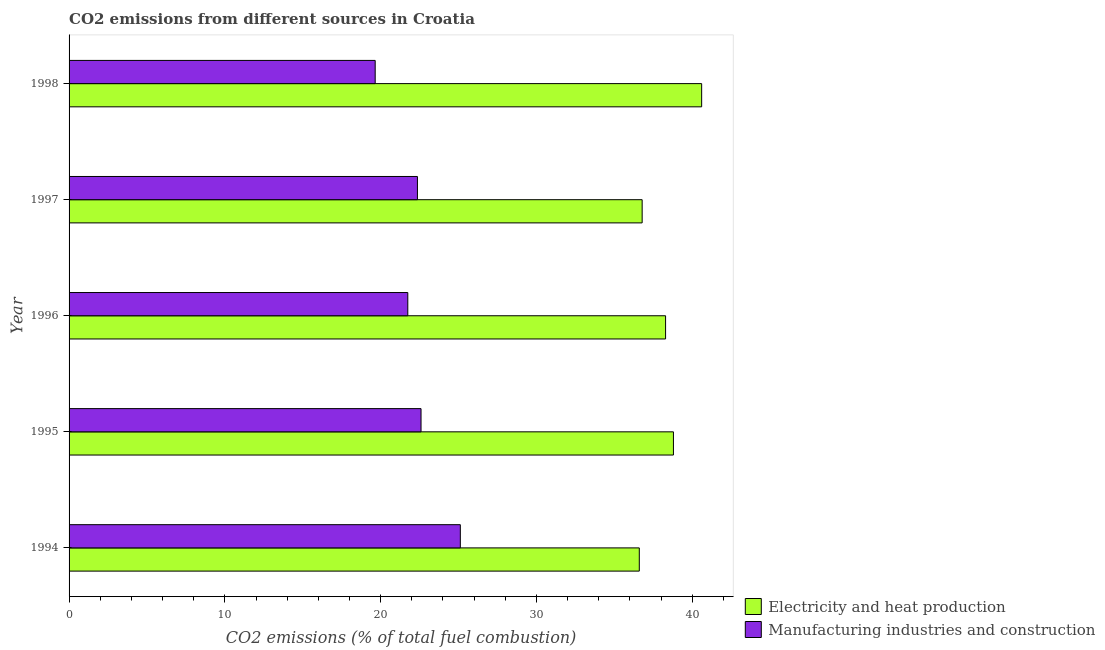Are the number of bars on each tick of the Y-axis equal?
Your answer should be very brief. Yes. How many bars are there on the 2nd tick from the top?
Offer a terse response. 2. How many bars are there on the 5th tick from the bottom?
Make the answer very short. 2. What is the label of the 1st group of bars from the top?
Provide a short and direct response. 1998. What is the co2 emissions due to electricity and heat production in 1998?
Provide a succinct answer. 40.61. Across all years, what is the maximum co2 emissions due to electricity and heat production?
Offer a terse response. 40.61. Across all years, what is the minimum co2 emissions due to manufacturing industries?
Your response must be concise. 19.65. In which year was the co2 emissions due to manufacturing industries maximum?
Ensure brevity in your answer.  1994. In which year was the co2 emissions due to manufacturing industries minimum?
Ensure brevity in your answer.  1998. What is the total co2 emissions due to manufacturing industries in the graph?
Provide a succinct answer. 111.47. What is the difference between the co2 emissions due to electricity and heat production in 1996 and that in 1998?
Provide a short and direct response. -2.32. What is the difference between the co2 emissions due to electricity and heat production in 1997 and the co2 emissions due to manufacturing industries in 1996?
Offer a terse response. 15.05. What is the average co2 emissions due to manufacturing industries per year?
Offer a terse response. 22.29. In the year 1996, what is the difference between the co2 emissions due to electricity and heat production and co2 emissions due to manufacturing industries?
Your response must be concise. 16.55. What is the ratio of the co2 emissions due to manufacturing industries in 1994 to that in 1995?
Provide a succinct answer. 1.11. Is the co2 emissions due to manufacturing industries in 1995 less than that in 1997?
Ensure brevity in your answer.  No. Is the difference between the co2 emissions due to manufacturing industries in 1996 and 1998 greater than the difference between the co2 emissions due to electricity and heat production in 1996 and 1998?
Your answer should be very brief. Yes. What is the difference between the highest and the second highest co2 emissions due to electricity and heat production?
Your answer should be compact. 1.81. What is the difference between the highest and the lowest co2 emissions due to manufacturing industries?
Offer a very short reply. 5.47. Is the sum of the co2 emissions due to manufacturing industries in 1994 and 1996 greater than the maximum co2 emissions due to electricity and heat production across all years?
Offer a very short reply. Yes. What does the 1st bar from the top in 1994 represents?
Make the answer very short. Manufacturing industries and construction. What does the 2nd bar from the bottom in 1997 represents?
Your answer should be compact. Manufacturing industries and construction. How many bars are there?
Offer a very short reply. 10. How many years are there in the graph?
Offer a very short reply. 5. Are the values on the major ticks of X-axis written in scientific E-notation?
Provide a succinct answer. No. What is the title of the graph?
Keep it short and to the point. CO2 emissions from different sources in Croatia. Does "Public credit registry" appear as one of the legend labels in the graph?
Ensure brevity in your answer.  No. What is the label or title of the X-axis?
Ensure brevity in your answer.  CO2 emissions (% of total fuel combustion). What is the label or title of the Y-axis?
Keep it short and to the point. Year. What is the CO2 emissions (% of total fuel combustion) in Electricity and heat production in 1994?
Ensure brevity in your answer.  36.61. What is the CO2 emissions (% of total fuel combustion) in Manufacturing industries and construction in 1994?
Ensure brevity in your answer.  25.12. What is the CO2 emissions (% of total fuel combustion) in Electricity and heat production in 1995?
Offer a very short reply. 38.8. What is the CO2 emissions (% of total fuel combustion) of Manufacturing industries and construction in 1995?
Give a very brief answer. 22.59. What is the CO2 emissions (% of total fuel combustion) of Electricity and heat production in 1996?
Ensure brevity in your answer.  38.29. What is the CO2 emissions (% of total fuel combustion) of Manufacturing industries and construction in 1996?
Ensure brevity in your answer.  21.74. What is the CO2 emissions (% of total fuel combustion) of Electricity and heat production in 1997?
Your response must be concise. 36.79. What is the CO2 emissions (% of total fuel combustion) in Manufacturing industries and construction in 1997?
Offer a terse response. 22.36. What is the CO2 emissions (% of total fuel combustion) of Electricity and heat production in 1998?
Make the answer very short. 40.61. What is the CO2 emissions (% of total fuel combustion) in Manufacturing industries and construction in 1998?
Make the answer very short. 19.65. Across all years, what is the maximum CO2 emissions (% of total fuel combustion) of Electricity and heat production?
Keep it short and to the point. 40.61. Across all years, what is the maximum CO2 emissions (% of total fuel combustion) in Manufacturing industries and construction?
Provide a short and direct response. 25.12. Across all years, what is the minimum CO2 emissions (% of total fuel combustion) in Electricity and heat production?
Offer a terse response. 36.61. Across all years, what is the minimum CO2 emissions (% of total fuel combustion) of Manufacturing industries and construction?
Offer a very short reply. 19.65. What is the total CO2 emissions (% of total fuel combustion) of Electricity and heat production in the graph?
Your response must be concise. 191.1. What is the total CO2 emissions (% of total fuel combustion) in Manufacturing industries and construction in the graph?
Your answer should be compact. 111.47. What is the difference between the CO2 emissions (% of total fuel combustion) of Electricity and heat production in 1994 and that in 1995?
Offer a very short reply. -2.19. What is the difference between the CO2 emissions (% of total fuel combustion) in Manufacturing industries and construction in 1994 and that in 1995?
Ensure brevity in your answer.  2.52. What is the difference between the CO2 emissions (% of total fuel combustion) in Electricity and heat production in 1994 and that in 1996?
Your answer should be compact. -1.69. What is the difference between the CO2 emissions (% of total fuel combustion) in Manufacturing industries and construction in 1994 and that in 1996?
Ensure brevity in your answer.  3.37. What is the difference between the CO2 emissions (% of total fuel combustion) of Electricity and heat production in 1994 and that in 1997?
Your response must be concise. -0.18. What is the difference between the CO2 emissions (% of total fuel combustion) of Manufacturing industries and construction in 1994 and that in 1997?
Your answer should be compact. 2.75. What is the difference between the CO2 emissions (% of total fuel combustion) in Electricity and heat production in 1994 and that in 1998?
Give a very brief answer. -4. What is the difference between the CO2 emissions (% of total fuel combustion) in Manufacturing industries and construction in 1994 and that in 1998?
Offer a very short reply. 5.47. What is the difference between the CO2 emissions (% of total fuel combustion) in Electricity and heat production in 1995 and that in 1996?
Offer a very short reply. 0.5. What is the difference between the CO2 emissions (% of total fuel combustion) of Manufacturing industries and construction in 1995 and that in 1996?
Keep it short and to the point. 0.85. What is the difference between the CO2 emissions (% of total fuel combustion) of Electricity and heat production in 1995 and that in 1997?
Your answer should be very brief. 2.01. What is the difference between the CO2 emissions (% of total fuel combustion) in Manufacturing industries and construction in 1995 and that in 1997?
Ensure brevity in your answer.  0.23. What is the difference between the CO2 emissions (% of total fuel combustion) in Electricity and heat production in 1995 and that in 1998?
Provide a short and direct response. -1.81. What is the difference between the CO2 emissions (% of total fuel combustion) in Manufacturing industries and construction in 1995 and that in 1998?
Offer a terse response. 2.94. What is the difference between the CO2 emissions (% of total fuel combustion) of Electricity and heat production in 1996 and that in 1997?
Your answer should be compact. 1.5. What is the difference between the CO2 emissions (% of total fuel combustion) of Manufacturing industries and construction in 1996 and that in 1997?
Give a very brief answer. -0.62. What is the difference between the CO2 emissions (% of total fuel combustion) in Electricity and heat production in 1996 and that in 1998?
Your response must be concise. -2.32. What is the difference between the CO2 emissions (% of total fuel combustion) in Manufacturing industries and construction in 1996 and that in 1998?
Your answer should be compact. 2.09. What is the difference between the CO2 emissions (% of total fuel combustion) in Electricity and heat production in 1997 and that in 1998?
Provide a short and direct response. -3.82. What is the difference between the CO2 emissions (% of total fuel combustion) of Manufacturing industries and construction in 1997 and that in 1998?
Your response must be concise. 2.71. What is the difference between the CO2 emissions (% of total fuel combustion) of Electricity and heat production in 1994 and the CO2 emissions (% of total fuel combustion) of Manufacturing industries and construction in 1995?
Ensure brevity in your answer.  14.01. What is the difference between the CO2 emissions (% of total fuel combustion) of Electricity and heat production in 1994 and the CO2 emissions (% of total fuel combustion) of Manufacturing industries and construction in 1996?
Ensure brevity in your answer.  14.86. What is the difference between the CO2 emissions (% of total fuel combustion) of Electricity and heat production in 1994 and the CO2 emissions (% of total fuel combustion) of Manufacturing industries and construction in 1997?
Your response must be concise. 14.24. What is the difference between the CO2 emissions (% of total fuel combustion) in Electricity and heat production in 1994 and the CO2 emissions (% of total fuel combustion) in Manufacturing industries and construction in 1998?
Offer a very short reply. 16.95. What is the difference between the CO2 emissions (% of total fuel combustion) in Electricity and heat production in 1995 and the CO2 emissions (% of total fuel combustion) in Manufacturing industries and construction in 1996?
Offer a terse response. 17.05. What is the difference between the CO2 emissions (% of total fuel combustion) of Electricity and heat production in 1995 and the CO2 emissions (% of total fuel combustion) of Manufacturing industries and construction in 1997?
Keep it short and to the point. 16.43. What is the difference between the CO2 emissions (% of total fuel combustion) in Electricity and heat production in 1995 and the CO2 emissions (% of total fuel combustion) in Manufacturing industries and construction in 1998?
Give a very brief answer. 19.15. What is the difference between the CO2 emissions (% of total fuel combustion) of Electricity and heat production in 1996 and the CO2 emissions (% of total fuel combustion) of Manufacturing industries and construction in 1997?
Your answer should be very brief. 15.93. What is the difference between the CO2 emissions (% of total fuel combustion) of Electricity and heat production in 1996 and the CO2 emissions (% of total fuel combustion) of Manufacturing industries and construction in 1998?
Your answer should be very brief. 18.64. What is the difference between the CO2 emissions (% of total fuel combustion) of Electricity and heat production in 1997 and the CO2 emissions (% of total fuel combustion) of Manufacturing industries and construction in 1998?
Your response must be concise. 17.14. What is the average CO2 emissions (% of total fuel combustion) in Electricity and heat production per year?
Make the answer very short. 38.22. What is the average CO2 emissions (% of total fuel combustion) in Manufacturing industries and construction per year?
Provide a short and direct response. 22.29. In the year 1994, what is the difference between the CO2 emissions (% of total fuel combustion) in Electricity and heat production and CO2 emissions (% of total fuel combustion) in Manufacturing industries and construction?
Give a very brief answer. 11.49. In the year 1995, what is the difference between the CO2 emissions (% of total fuel combustion) in Electricity and heat production and CO2 emissions (% of total fuel combustion) in Manufacturing industries and construction?
Give a very brief answer. 16.2. In the year 1996, what is the difference between the CO2 emissions (% of total fuel combustion) in Electricity and heat production and CO2 emissions (% of total fuel combustion) in Manufacturing industries and construction?
Provide a succinct answer. 16.55. In the year 1997, what is the difference between the CO2 emissions (% of total fuel combustion) of Electricity and heat production and CO2 emissions (% of total fuel combustion) of Manufacturing industries and construction?
Your answer should be very brief. 14.43. In the year 1998, what is the difference between the CO2 emissions (% of total fuel combustion) of Electricity and heat production and CO2 emissions (% of total fuel combustion) of Manufacturing industries and construction?
Your answer should be very brief. 20.96. What is the ratio of the CO2 emissions (% of total fuel combustion) in Electricity and heat production in 1994 to that in 1995?
Ensure brevity in your answer.  0.94. What is the ratio of the CO2 emissions (% of total fuel combustion) in Manufacturing industries and construction in 1994 to that in 1995?
Offer a very short reply. 1.11. What is the ratio of the CO2 emissions (% of total fuel combustion) in Electricity and heat production in 1994 to that in 1996?
Your answer should be compact. 0.96. What is the ratio of the CO2 emissions (% of total fuel combustion) in Manufacturing industries and construction in 1994 to that in 1996?
Your answer should be very brief. 1.16. What is the ratio of the CO2 emissions (% of total fuel combustion) in Manufacturing industries and construction in 1994 to that in 1997?
Provide a short and direct response. 1.12. What is the ratio of the CO2 emissions (% of total fuel combustion) in Electricity and heat production in 1994 to that in 1998?
Offer a terse response. 0.9. What is the ratio of the CO2 emissions (% of total fuel combustion) in Manufacturing industries and construction in 1994 to that in 1998?
Your answer should be compact. 1.28. What is the ratio of the CO2 emissions (% of total fuel combustion) in Electricity and heat production in 1995 to that in 1996?
Give a very brief answer. 1.01. What is the ratio of the CO2 emissions (% of total fuel combustion) of Manufacturing industries and construction in 1995 to that in 1996?
Your answer should be compact. 1.04. What is the ratio of the CO2 emissions (% of total fuel combustion) in Electricity and heat production in 1995 to that in 1997?
Your response must be concise. 1.05. What is the ratio of the CO2 emissions (% of total fuel combustion) of Manufacturing industries and construction in 1995 to that in 1997?
Your answer should be compact. 1.01. What is the ratio of the CO2 emissions (% of total fuel combustion) in Electricity and heat production in 1995 to that in 1998?
Give a very brief answer. 0.96. What is the ratio of the CO2 emissions (% of total fuel combustion) of Manufacturing industries and construction in 1995 to that in 1998?
Make the answer very short. 1.15. What is the ratio of the CO2 emissions (% of total fuel combustion) in Electricity and heat production in 1996 to that in 1997?
Provide a succinct answer. 1.04. What is the ratio of the CO2 emissions (% of total fuel combustion) in Manufacturing industries and construction in 1996 to that in 1997?
Your answer should be compact. 0.97. What is the ratio of the CO2 emissions (% of total fuel combustion) in Electricity and heat production in 1996 to that in 1998?
Give a very brief answer. 0.94. What is the ratio of the CO2 emissions (% of total fuel combustion) of Manufacturing industries and construction in 1996 to that in 1998?
Your answer should be compact. 1.11. What is the ratio of the CO2 emissions (% of total fuel combustion) in Electricity and heat production in 1997 to that in 1998?
Provide a short and direct response. 0.91. What is the ratio of the CO2 emissions (% of total fuel combustion) of Manufacturing industries and construction in 1997 to that in 1998?
Keep it short and to the point. 1.14. What is the difference between the highest and the second highest CO2 emissions (% of total fuel combustion) in Electricity and heat production?
Ensure brevity in your answer.  1.81. What is the difference between the highest and the second highest CO2 emissions (% of total fuel combustion) of Manufacturing industries and construction?
Keep it short and to the point. 2.52. What is the difference between the highest and the lowest CO2 emissions (% of total fuel combustion) in Electricity and heat production?
Ensure brevity in your answer.  4. What is the difference between the highest and the lowest CO2 emissions (% of total fuel combustion) of Manufacturing industries and construction?
Your response must be concise. 5.47. 